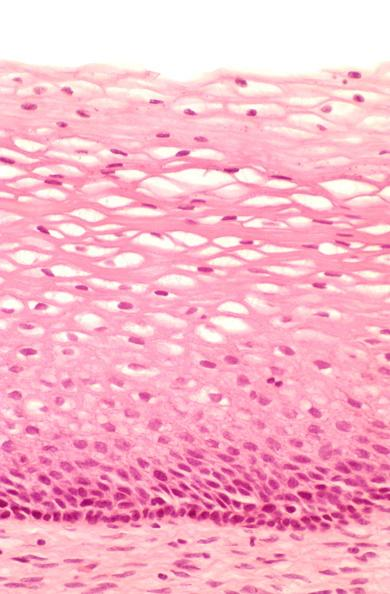what is present?
Answer the question using a single word or phrase. Female reproductive 